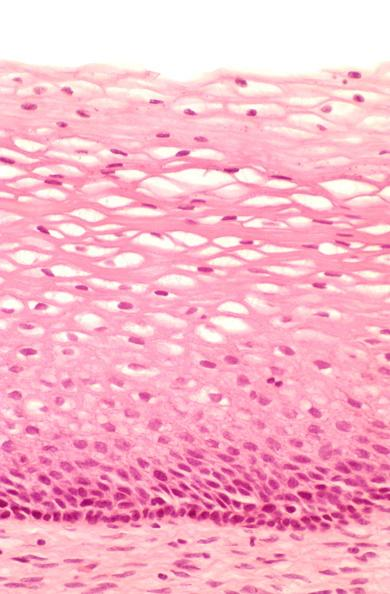what is present?
Answer the question using a single word or phrase. Female reproductive 